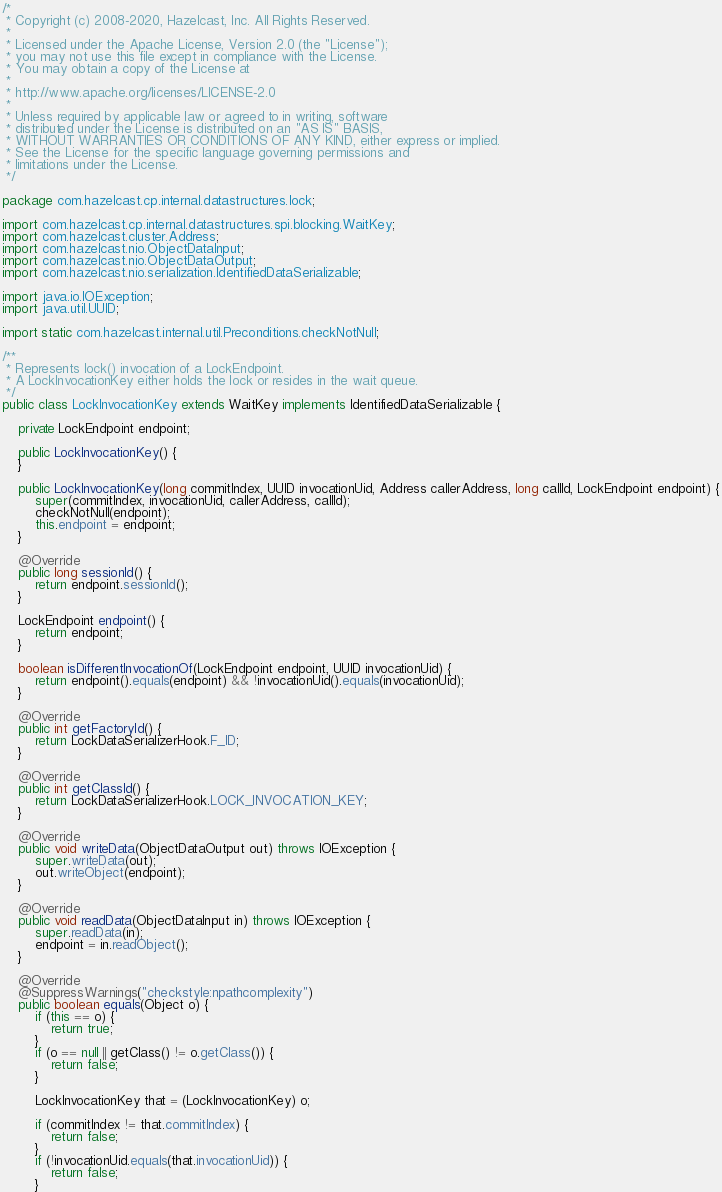<code> <loc_0><loc_0><loc_500><loc_500><_Java_>/*
 * Copyright (c) 2008-2020, Hazelcast, Inc. All Rights Reserved.
 *
 * Licensed under the Apache License, Version 2.0 (the "License");
 * you may not use this file except in compliance with the License.
 * You may obtain a copy of the License at
 *
 * http://www.apache.org/licenses/LICENSE-2.0
 *
 * Unless required by applicable law or agreed to in writing, software
 * distributed under the License is distributed on an "AS IS" BASIS,
 * WITHOUT WARRANTIES OR CONDITIONS OF ANY KIND, either express or implied.
 * See the License for the specific language governing permissions and
 * limitations under the License.
 */

package com.hazelcast.cp.internal.datastructures.lock;

import com.hazelcast.cp.internal.datastructures.spi.blocking.WaitKey;
import com.hazelcast.cluster.Address;
import com.hazelcast.nio.ObjectDataInput;
import com.hazelcast.nio.ObjectDataOutput;
import com.hazelcast.nio.serialization.IdentifiedDataSerializable;

import java.io.IOException;
import java.util.UUID;

import static com.hazelcast.internal.util.Preconditions.checkNotNull;

/**
 * Represents lock() invocation of a LockEndpoint.
 * A LockInvocationKey either holds the lock or resides in the wait queue.
 */
public class LockInvocationKey extends WaitKey implements IdentifiedDataSerializable {

    private LockEndpoint endpoint;

    public LockInvocationKey() {
    }

    public LockInvocationKey(long commitIndex, UUID invocationUid, Address callerAddress, long callId, LockEndpoint endpoint) {
        super(commitIndex, invocationUid, callerAddress, callId);
        checkNotNull(endpoint);
        this.endpoint = endpoint;
    }

    @Override
    public long sessionId() {
        return endpoint.sessionId();
    }

    LockEndpoint endpoint() {
        return endpoint;
    }

    boolean isDifferentInvocationOf(LockEndpoint endpoint, UUID invocationUid) {
        return endpoint().equals(endpoint) && !invocationUid().equals(invocationUid);
    }

    @Override
    public int getFactoryId() {
        return LockDataSerializerHook.F_ID;
    }

    @Override
    public int getClassId() {
        return LockDataSerializerHook.LOCK_INVOCATION_KEY;
    }

    @Override
    public void writeData(ObjectDataOutput out) throws IOException {
        super.writeData(out);
        out.writeObject(endpoint);
    }

    @Override
    public void readData(ObjectDataInput in) throws IOException {
        super.readData(in);
        endpoint = in.readObject();
    }

    @Override
    @SuppressWarnings("checkstyle:npathcomplexity")
    public boolean equals(Object o) {
        if (this == o) {
            return true;
        }
        if (o == null || getClass() != o.getClass()) {
            return false;
        }

        LockInvocationKey that = (LockInvocationKey) o;

        if (commitIndex != that.commitIndex) {
            return false;
        }
        if (!invocationUid.equals(that.invocationUid)) {
            return false;
        }</code> 